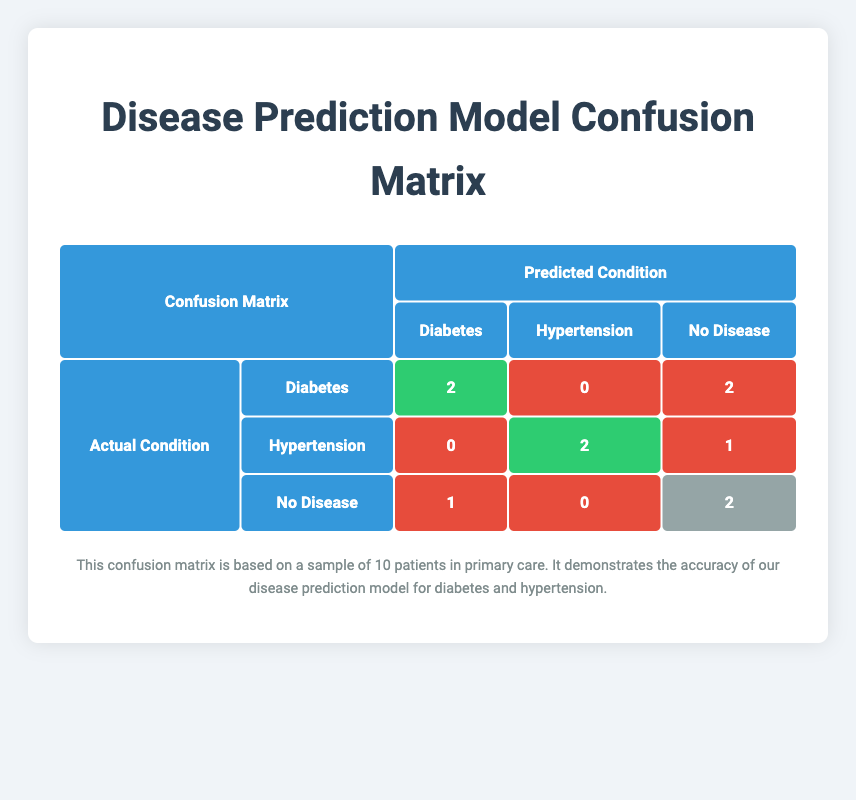What is the true positive count for Diabetes? The table shows that there are 2 true positives for Diabetes, which represents the cases where the actual condition was Diabetes, and the predicted condition was also Diabetes.
Answer: 2 How many false negatives are there for Hypertension? The table indicates that there is 1 false negative for Hypertension. This number represents the cases where the actual condition was Hypertension, but the prediction indicated No Hypertension.
Answer: 1 What is the predicted condition for patient P002? Referring to the evaluation data, patient P002 has an actual condition of Diabetes, but the predicted condition is No Diabetes.
Answer: No Diabetes Is the model accurate in predicting No Disease for patients who do not have any diseases? Yes, the model has a true negative count of 2 for No Disease, which means it correctly predicted No Disease in those two cases.
Answer: Yes How many total false positives were recorded across all conditions? There are 1 false positive for Diabetes and 1 for Hypertension, totaling 2 false positives. The calculation is 1 + 1 = 2.
Answer: 2 What is the combination of true positive and false negative counts for Hypertension? For Hypertension, the true positive count is 2, and the false negative count is 1. Therefore, the combination is 2 + 1 = 3.
Answer: 3 Did the model predict No Disease for patient P007? No, the table shows that patient P007, who had No Disease as the actual condition, was predicted to have Diabetes.
Answer: No What is the precision of the model for predicting Diabetes? Precision is calculated as true positives divided by the sum of true positives and false positives. Here, there are 2 true positives and 1 false positive for Diabetes, giving a precision of 2/(2+1) = 2/3 ≈ 0.67.
Answer: 0.67 How many total patients were actually diagnosed with Hypertension? In the table, there are 2 true positives and 1 false negative for Hypertension, making a total of 2 + 1 = 3 patients who had Hypertension.
Answer: 3 What is the confidence level for the prediction of No Disease in patient P009? According to the data, the prediction confidence for No Disease in patient P009 is 0.98, which reflects the model's high certainty in this prediction.
Answer: 0.98 